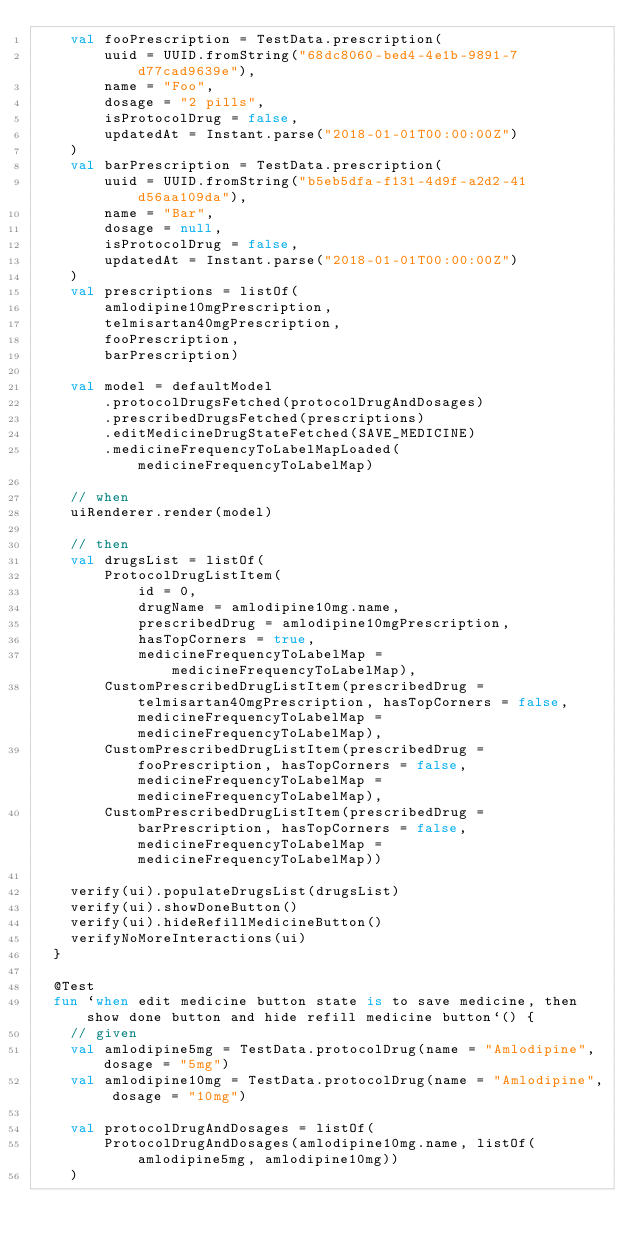Convert code to text. <code><loc_0><loc_0><loc_500><loc_500><_Kotlin_>    val fooPrescription = TestData.prescription(
        uuid = UUID.fromString("68dc8060-bed4-4e1b-9891-7d77cad9639e"),
        name = "Foo",
        dosage = "2 pills",
        isProtocolDrug = false,
        updatedAt = Instant.parse("2018-01-01T00:00:00Z")
    )
    val barPrescription = TestData.prescription(
        uuid = UUID.fromString("b5eb5dfa-f131-4d9f-a2d2-41d56aa109da"),
        name = "Bar",
        dosage = null,
        isProtocolDrug = false,
        updatedAt = Instant.parse("2018-01-01T00:00:00Z")
    )
    val prescriptions = listOf(
        amlodipine10mgPrescription,
        telmisartan40mgPrescription,
        fooPrescription,
        barPrescription)

    val model = defaultModel
        .protocolDrugsFetched(protocolDrugAndDosages)
        .prescribedDrugsFetched(prescriptions)
        .editMedicineDrugStateFetched(SAVE_MEDICINE)
        .medicineFrequencyToLabelMapLoaded(medicineFrequencyToLabelMap)

    // when
    uiRenderer.render(model)

    // then
    val drugsList = listOf(
        ProtocolDrugListItem(
            id = 0,
            drugName = amlodipine10mg.name,
            prescribedDrug = amlodipine10mgPrescription,
            hasTopCorners = true,
            medicineFrequencyToLabelMap = medicineFrequencyToLabelMap),
        CustomPrescribedDrugListItem(prescribedDrug = telmisartan40mgPrescription, hasTopCorners = false, medicineFrequencyToLabelMap = medicineFrequencyToLabelMap),
        CustomPrescribedDrugListItem(prescribedDrug = fooPrescription, hasTopCorners = false, medicineFrequencyToLabelMap = medicineFrequencyToLabelMap),
        CustomPrescribedDrugListItem(prescribedDrug = barPrescription, hasTopCorners = false, medicineFrequencyToLabelMap = medicineFrequencyToLabelMap))

    verify(ui).populateDrugsList(drugsList)
    verify(ui).showDoneButton()
    verify(ui).hideRefillMedicineButton()
    verifyNoMoreInteractions(ui)
  }

  @Test
  fun `when edit medicine button state is to save medicine, then show done button and hide refill medicine button`() {
    // given
    val amlodipine5mg = TestData.protocolDrug(name = "Amlodipine", dosage = "5mg")
    val amlodipine10mg = TestData.protocolDrug(name = "Amlodipine", dosage = "10mg")

    val protocolDrugAndDosages = listOf(
        ProtocolDrugAndDosages(amlodipine10mg.name, listOf(amlodipine5mg, amlodipine10mg))
    )
</code> 